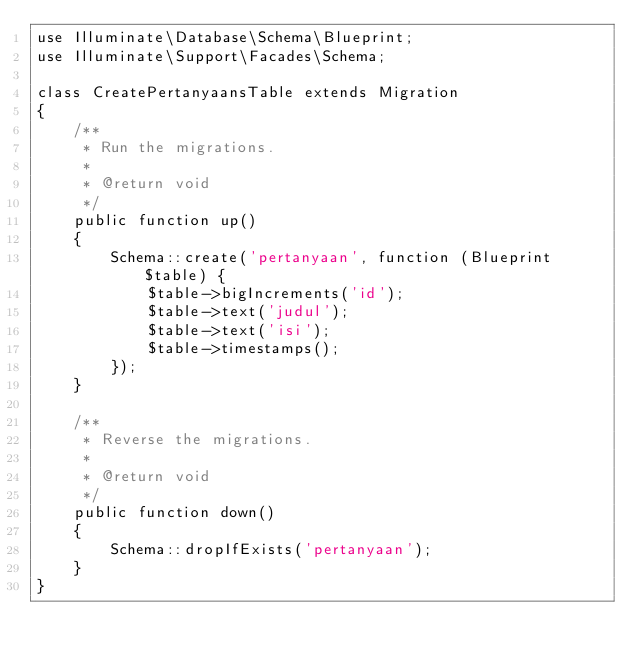Convert code to text. <code><loc_0><loc_0><loc_500><loc_500><_PHP_>use Illuminate\Database\Schema\Blueprint;
use Illuminate\Support\Facades\Schema;

class CreatePertanyaansTable extends Migration
{
    /**
     * Run the migrations.
     *
     * @return void
     */
    public function up()
    {
        Schema::create('pertanyaan', function (Blueprint $table) {
            $table->bigIncrements('id');
            $table->text('judul');
            $table->text('isi');
            $table->timestamps();
        });
    }

    /**
     * Reverse the migrations.
     *
     * @return void
     */
    public function down()
    {
        Schema::dropIfExists('pertanyaan');
    }
}
</code> 